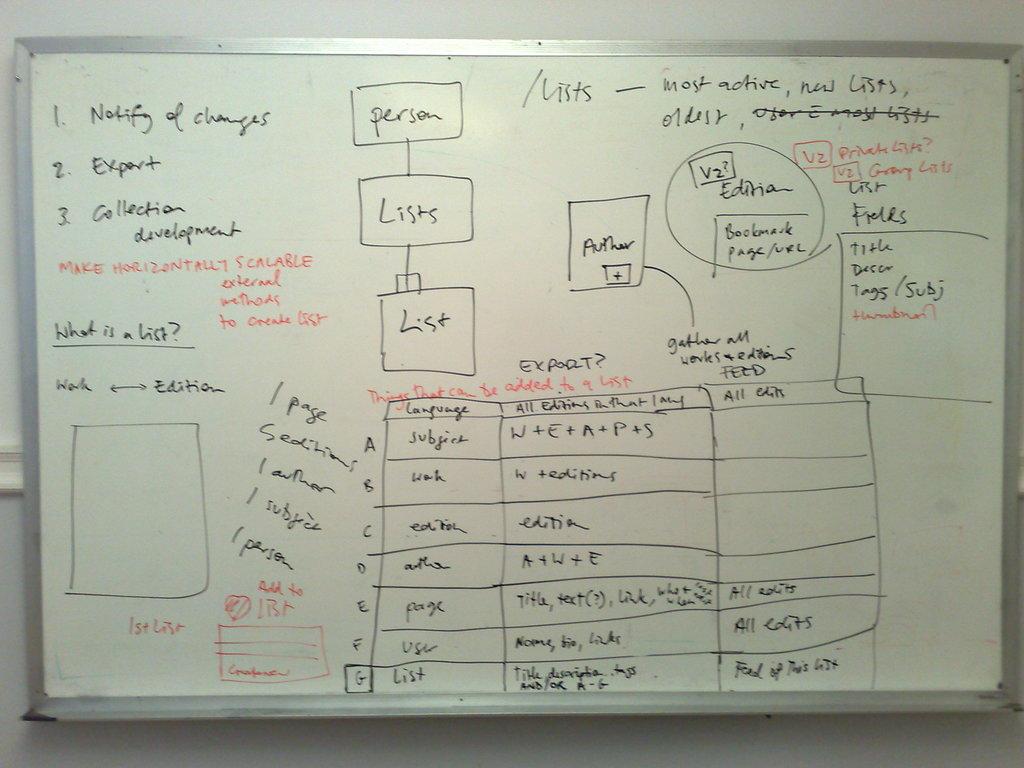What is #3 on the list?
Your response must be concise. Collection development. 